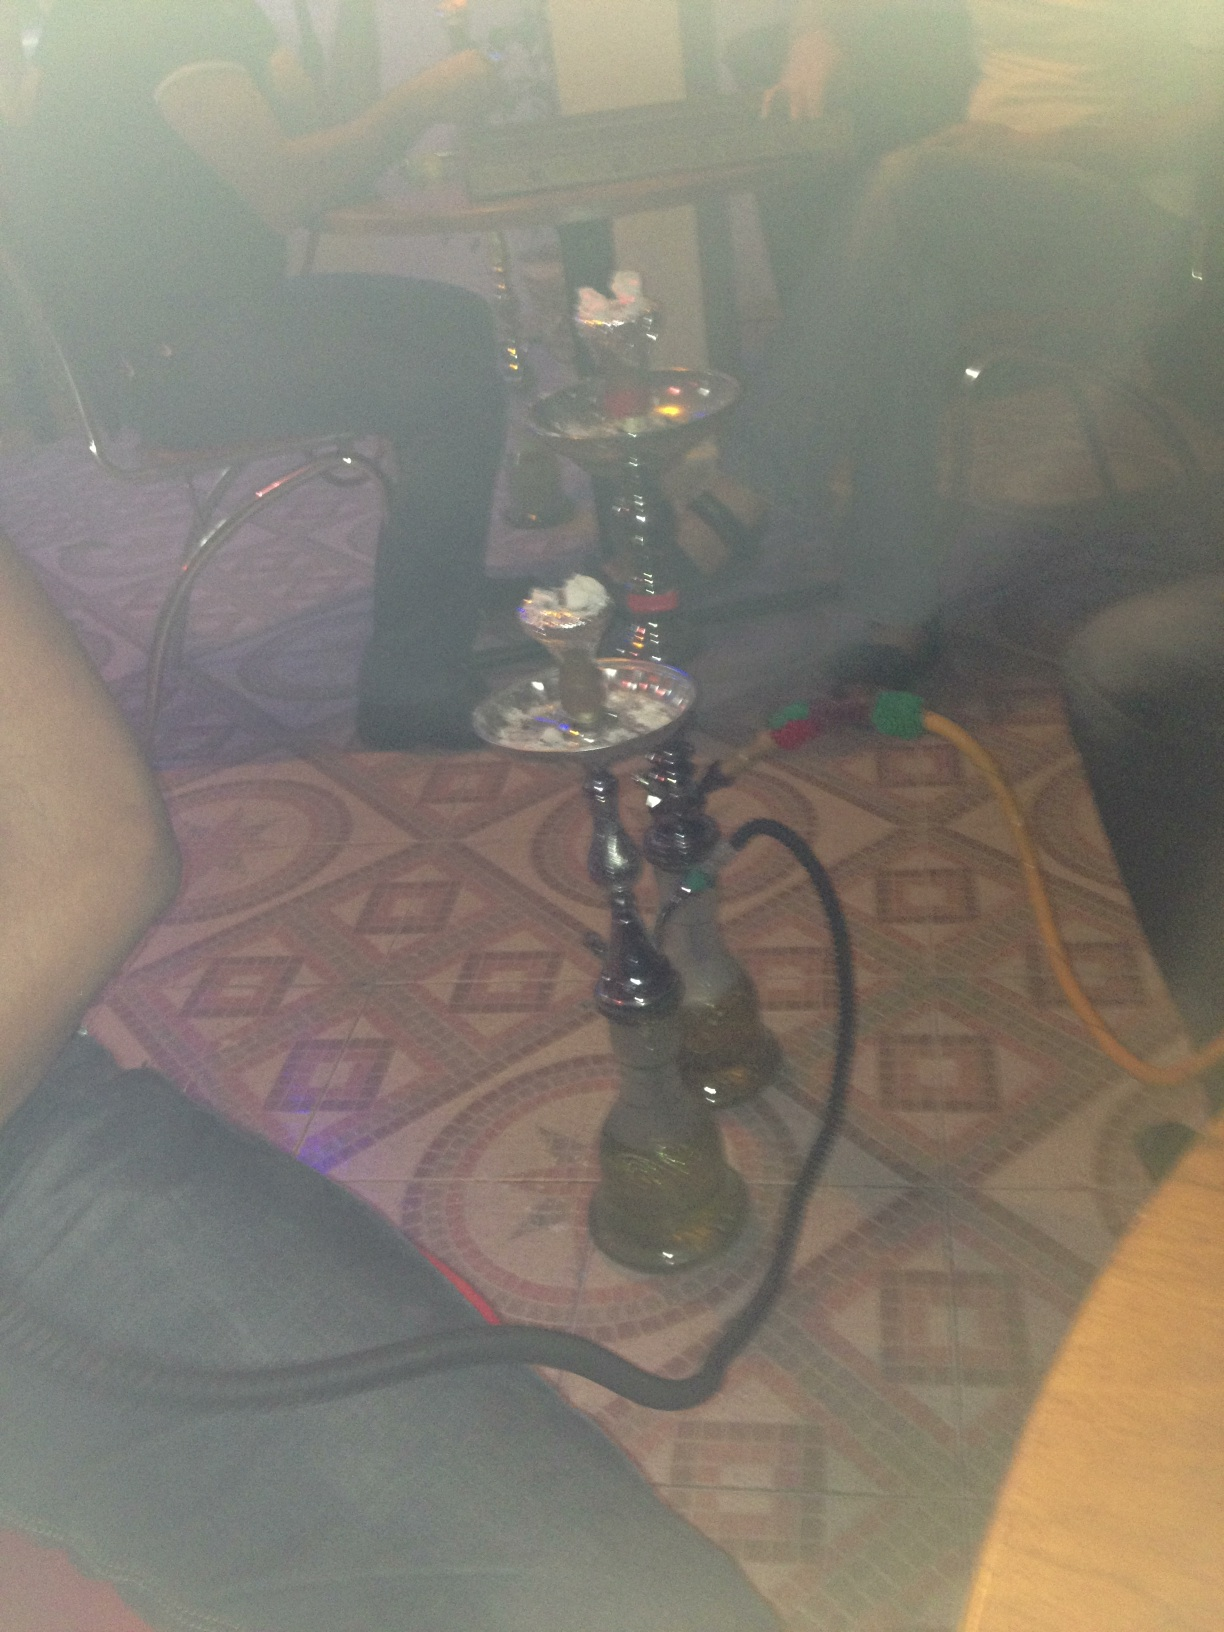Can you tell me more about the context in which a hookah is usually used? Hookahs are traditionally used in social settings, often found in hookah bars, cafes, or at parties. The act of smoking a hookah is a leisurely activity that can last for an hour or more. It's frequently enjoyed in groups, where the hose is passed from person to person, and it's also associated with cultural practices in Middle Eastern countries.  Does this image give you any clues about the setting where this hookah is being used? From the image, it appears that the hookah is being used in an indoor, casual setting, possibly a home or private gathering place. The presence of multiple hoses suggests it's intended for group use, indicating a social atmosphere where participants can relax and converse while sharing the hookah. 